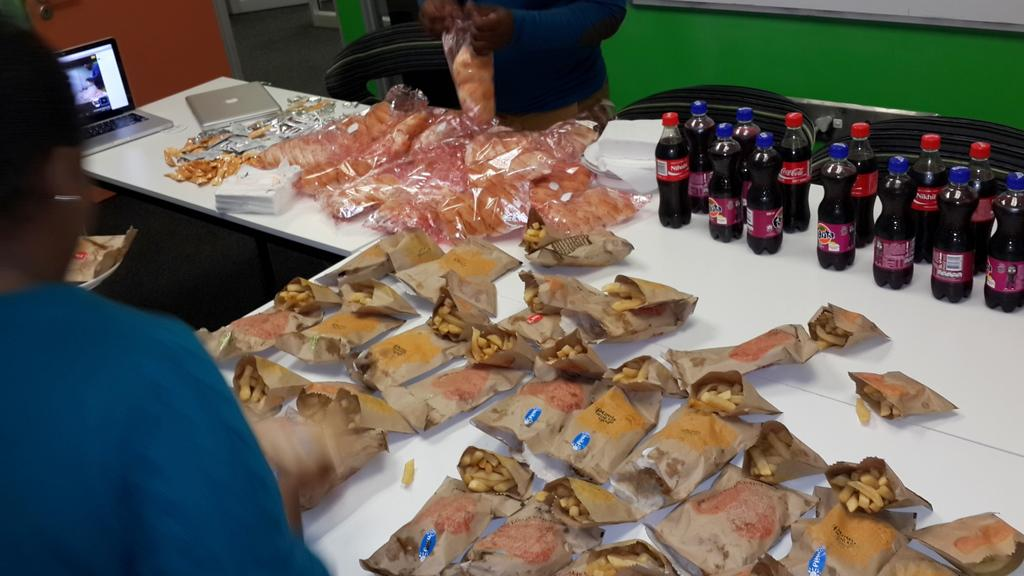What objects are on the white table in the image? There are laptops, soft drink bottles, plates, tissue papers, and food packets with food on the white table. What is the man holding in the image? The man is holding a food packet. What might be used for cleaning or wiping in the image? Tissue papers are present on the white table for cleaning or wiping. What line can be seen on the calendar in the image? There is no calendar present in the image. How does the man blow the candles on the cake in the image? There is no cake or candles present in the image, so it is not possible to answer that question. 